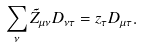<formula> <loc_0><loc_0><loc_500><loc_500>\sum _ { \nu } \tilde { Z } _ { \mu \nu } D _ { \nu \tau } = z _ { \tau } D _ { \mu \tau } .</formula> 